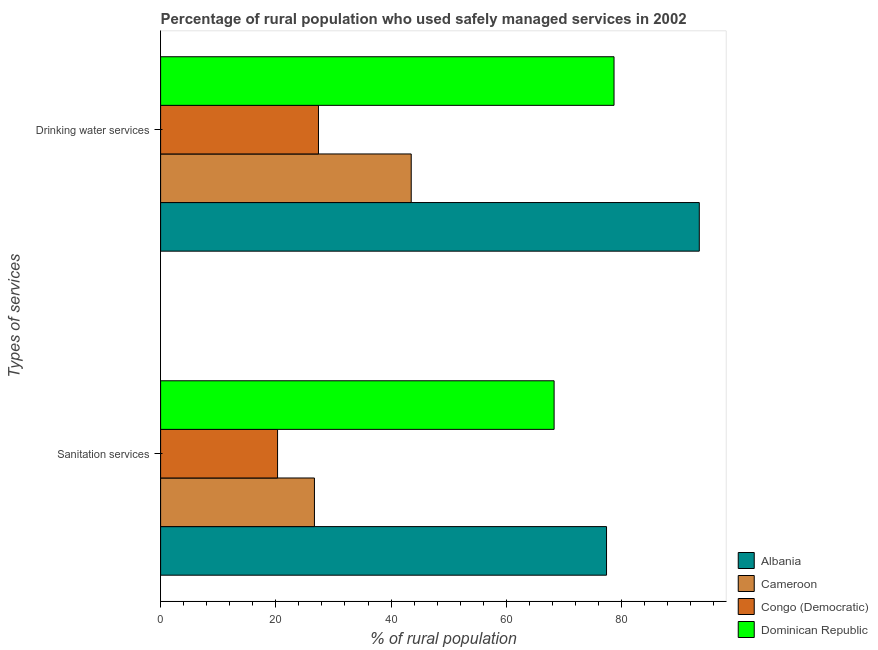How many different coloured bars are there?
Your response must be concise. 4. How many groups of bars are there?
Provide a short and direct response. 2. Are the number of bars per tick equal to the number of legend labels?
Provide a short and direct response. Yes. Are the number of bars on each tick of the Y-axis equal?
Offer a terse response. Yes. What is the label of the 2nd group of bars from the top?
Keep it short and to the point. Sanitation services. What is the percentage of rural population who used sanitation services in Dominican Republic?
Offer a terse response. 68.3. Across all countries, what is the maximum percentage of rural population who used sanitation services?
Provide a short and direct response. 77.4. Across all countries, what is the minimum percentage of rural population who used sanitation services?
Offer a very short reply. 20.3. In which country was the percentage of rural population who used sanitation services maximum?
Your answer should be very brief. Albania. In which country was the percentage of rural population who used sanitation services minimum?
Give a very brief answer. Congo (Democratic). What is the total percentage of rural population who used sanitation services in the graph?
Offer a terse response. 192.7. What is the difference between the percentage of rural population who used sanitation services in Albania and that in Cameroon?
Give a very brief answer. 50.7. What is the difference between the percentage of rural population who used drinking water services in Dominican Republic and the percentage of rural population who used sanitation services in Cameroon?
Your answer should be compact. 52. What is the average percentage of rural population who used sanitation services per country?
Give a very brief answer. 48.17. What is the difference between the percentage of rural population who used drinking water services and percentage of rural population who used sanitation services in Albania?
Keep it short and to the point. 16.1. In how many countries, is the percentage of rural population who used sanitation services greater than 16 %?
Give a very brief answer. 4. What is the ratio of the percentage of rural population who used drinking water services in Dominican Republic to that in Cameroon?
Ensure brevity in your answer.  1.81. Is the percentage of rural population who used drinking water services in Cameroon less than that in Congo (Democratic)?
Ensure brevity in your answer.  No. In how many countries, is the percentage of rural population who used drinking water services greater than the average percentage of rural population who used drinking water services taken over all countries?
Provide a short and direct response. 2. What does the 2nd bar from the top in Sanitation services represents?
Your response must be concise. Congo (Democratic). What does the 2nd bar from the bottom in Sanitation services represents?
Provide a short and direct response. Cameroon. Are all the bars in the graph horizontal?
Ensure brevity in your answer.  Yes. How many countries are there in the graph?
Ensure brevity in your answer.  4. Are the values on the major ticks of X-axis written in scientific E-notation?
Give a very brief answer. No. Where does the legend appear in the graph?
Provide a short and direct response. Bottom right. How are the legend labels stacked?
Give a very brief answer. Vertical. What is the title of the graph?
Ensure brevity in your answer.  Percentage of rural population who used safely managed services in 2002. What is the label or title of the X-axis?
Make the answer very short. % of rural population. What is the label or title of the Y-axis?
Make the answer very short. Types of services. What is the % of rural population in Albania in Sanitation services?
Your answer should be compact. 77.4. What is the % of rural population of Cameroon in Sanitation services?
Provide a short and direct response. 26.7. What is the % of rural population of Congo (Democratic) in Sanitation services?
Make the answer very short. 20.3. What is the % of rural population in Dominican Republic in Sanitation services?
Your answer should be compact. 68.3. What is the % of rural population of Albania in Drinking water services?
Make the answer very short. 93.5. What is the % of rural population of Cameroon in Drinking water services?
Provide a succinct answer. 43.5. What is the % of rural population of Congo (Democratic) in Drinking water services?
Ensure brevity in your answer.  27.4. What is the % of rural population in Dominican Republic in Drinking water services?
Give a very brief answer. 78.7. Across all Types of services, what is the maximum % of rural population of Albania?
Make the answer very short. 93.5. Across all Types of services, what is the maximum % of rural population in Cameroon?
Offer a terse response. 43.5. Across all Types of services, what is the maximum % of rural population in Congo (Democratic)?
Ensure brevity in your answer.  27.4. Across all Types of services, what is the maximum % of rural population of Dominican Republic?
Your answer should be very brief. 78.7. Across all Types of services, what is the minimum % of rural population of Albania?
Offer a very short reply. 77.4. Across all Types of services, what is the minimum % of rural population in Cameroon?
Provide a short and direct response. 26.7. Across all Types of services, what is the minimum % of rural population in Congo (Democratic)?
Keep it short and to the point. 20.3. Across all Types of services, what is the minimum % of rural population in Dominican Republic?
Keep it short and to the point. 68.3. What is the total % of rural population of Albania in the graph?
Offer a very short reply. 170.9. What is the total % of rural population of Cameroon in the graph?
Make the answer very short. 70.2. What is the total % of rural population of Congo (Democratic) in the graph?
Provide a short and direct response. 47.7. What is the total % of rural population in Dominican Republic in the graph?
Keep it short and to the point. 147. What is the difference between the % of rural population of Albania in Sanitation services and that in Drinking water services?
Your answer should be very brief. -16.1. What is the difference between the % of rural population of Cameroon in Sanitation services and that in Drinking water services?
Your answer should be very brief. -16.8. What is the difference between the % of rural population of Congo (Democratic) in Sanitation services and that in Drinking water services?
Keep it short and to the point. -7.1. What is the difference between the % of rural population in Albania in Sanitation services and the % of rural population in Cameroon in Drinking water services?
Your response must be concise. 33.9. What is the difference between the % of rural population of Cameroon in Sanitation services and the % of rural population of Congo (Democratic) in Drinking water services?
Your response must be concise. -0.7. What is the difference between the % of rural population of Cameroon in Sanitation services and the % of rural population of Dominican Republic in Drinking water services?
Your response must be concise. -52. What is the difference between the % of rural population in Congo (Democratic) in Sanitation services and the % of rural population in Dominican Republic in Drinking water services?
Ensure brevity in your answer.  -58.4. What is the average % of rural population in Albania per Types of services?
Make the answer very short. 85.45. What is the average % of rural population in Cameroon per Types of services?
Offer a very short reply. 35.1. What is the average % of rural population of Congo (Democratic) per Types of services?
Offer a very short reply. 23.85. What is the average % of rural population of Dominican Republic per Types of services?
Your answer should be very brief. 73.5. What is the difference between the % of rural population of Albania and % of rural population of Cameroon in Sanitation services?
Provide a short and direct response. 50.7. What is the difference between the % of rural population of Albania and % of rural population of Congo (Democratic) in Sanitation services?
Provide a short and direct response. 57.1. What is the difference between the % of rural population in Cameroon and % of rural population in Congo (Democratic) in Sanitation services?
Keep it short and to the point. 6.4. What is the difference between the % of rural population of Cameroon and % of rural population of Dominican Republic in Sanitation services?
Offer a very short reply. -41.6. What is the difference between the % of rural population of Congo (Democratic) and % of rural population of Dominican Republic in Sanitation services?
Provide a succinct answer. -48. What is the difference between the % of rural population in Albania and % of rural population in Congo (Democratic) in Drinking water services?
Give a very brief answer. 66.1. What is the difference between the % of rural population of Cameroon and % of rural population of Dominican Republic in Drinking water services?
Make the answer very short. -35.2. What is the difference between the % of rural population in Congo (Democratic) and % of rural population in Dominican Republic in Drinking water services?
Give a very brief answer. -51.3. What is the ratio of the % of rural population of Albania in Sanitation services to that in Drinking water services?
Your answer should be very brief. 0.83. What is the ratio of the % of rural population of Cameroon in Sanitation services to that in Drinking water services?
Your response must be concise. 0.61. What is the ratio of the % of rural population of Congo (Democratic) in Sanitation services to that in Drinking water services?
Give a very brief answer. 0.74. What is the ratio of the % of rural population in Dominican Republic in Sanitation services to that in Drinking water services?
Ensure brevity in your answer.  0.87. What is the difference between the highest and the second highest % of rural population in Cameroon?
Your answer should be very brief. 16.8. What is the difference between the highest and the lowest % of rural population of Congo (Democratic)?
Provide a short and direct response. 7.1. 